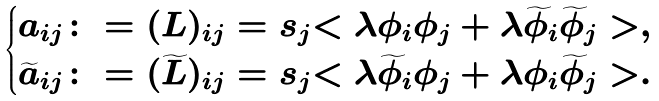<formula> <loc_0><loc_0><loc_500><loc_500>\begin{cases} a _ { i j } \colon = ( L ) _ { i j } = s _ { j } { < \lambda \phi _ { i } \phi _ { j } + \lambda \widetilde { \phi } _ { i } \widetilde { \phi } _ { j } > } , \\ \widetilde { a } _ { i j } \colon = ( \widetilde { L } ) _ { i j } = s _ { j } { < \lambda \widetilde { \phi } _ { i } \phi _ { j } + \lambda \phi _ { i } \widetilde { \phi } _ { j } > } . \end{cases}</formula> 